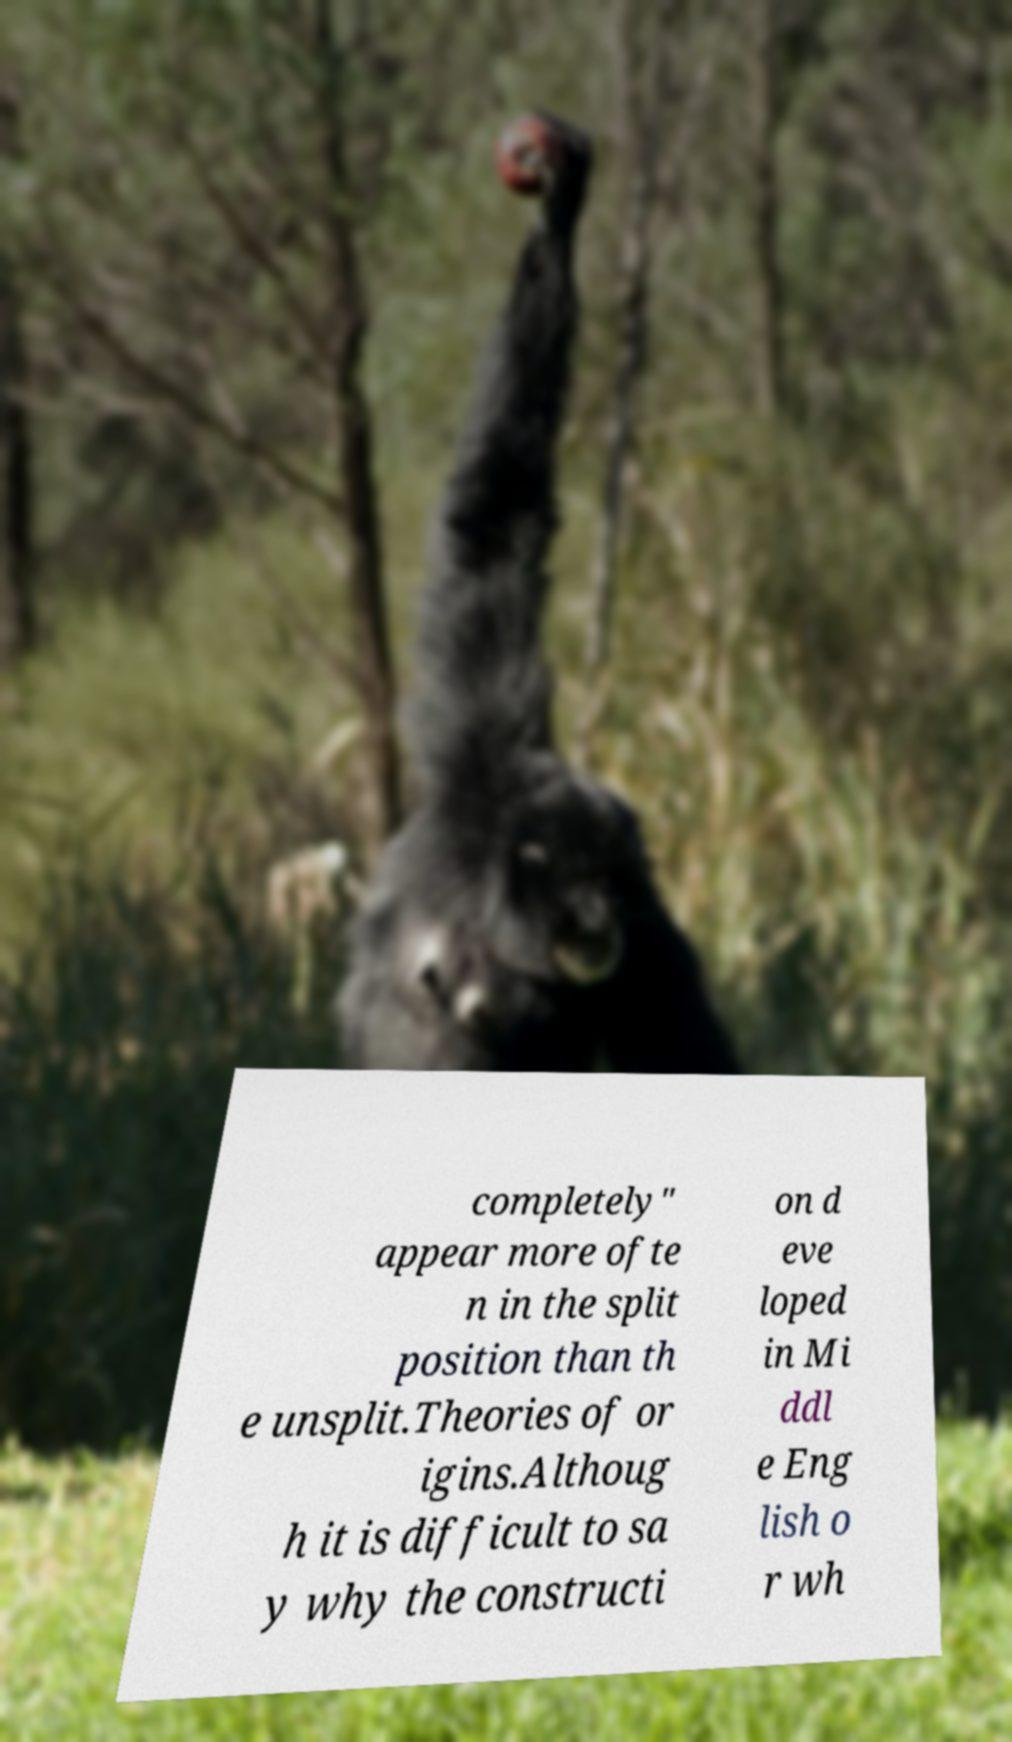Please read and relay the text visible in this image. What does it say? completely" appear more ofte n in the split position than th e unsplit.Theories of or igins.Althoug h it is difficult to sa y why the constructi on d eve loped in Mi ddl e Eng lish o r wh 